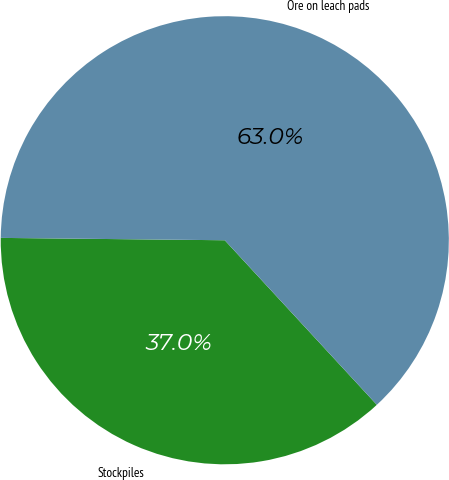Convert chart to OTSL. <chart><loc_0><loc_0><loc_500><loc_500><pie_chart><fcel>Stockpiles<fcel>Ore on leach pads<nl><fcel>37.04%<fcel>62.96%<nl></chart> 